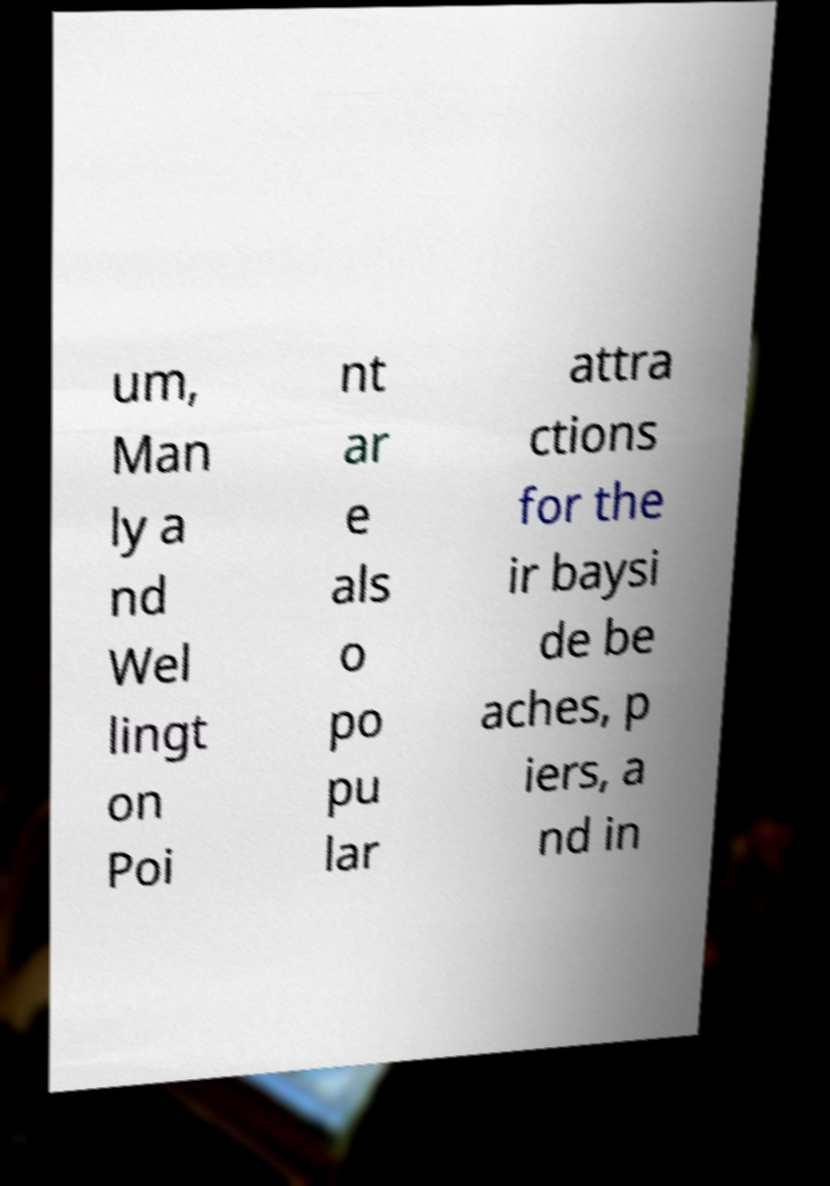What messages or text are displayed in this image? I need them in a readable, typed format. um, Man ly a nd Wel lingt on Poi nt ar e als o po pu lar attra ctions for the ir baysi de be aches, p iers, a nd in 